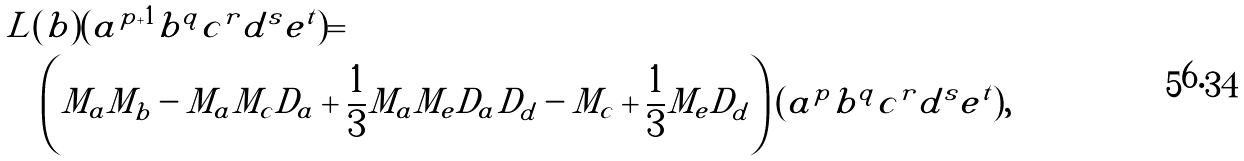<formula> <loc_0><loc_0><loc_500><loc_500>& L ( b ) ( a ^ { p + 1 } b ^ { q } c ^ { r } d ^ { s } e ^ { t } ) = \\ & \quad \left ( M _ { a } M _ { b } - M _ { a } M _ { c } D _ { a } + \frac { 1 } { 3 } M _ { a } M _ { e } D _ { a } D _ { d } - M _ { c } + \frac { 1 } { 3 } M _ { e } D _ { d } \right ) ( a ^ { p } b ^ { q } c ^ { r } d ^ { s } e ^ { t } ) ,</formula> 